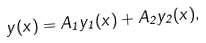Convert formula to latex. <formula><loc_0><loc_0><loc_500><loc_500>y ( x ) = A _ { 1 } y _ { 1 } ( x ) + A _ { 2 } y _ { 2 } ( x ) ,</formula> 